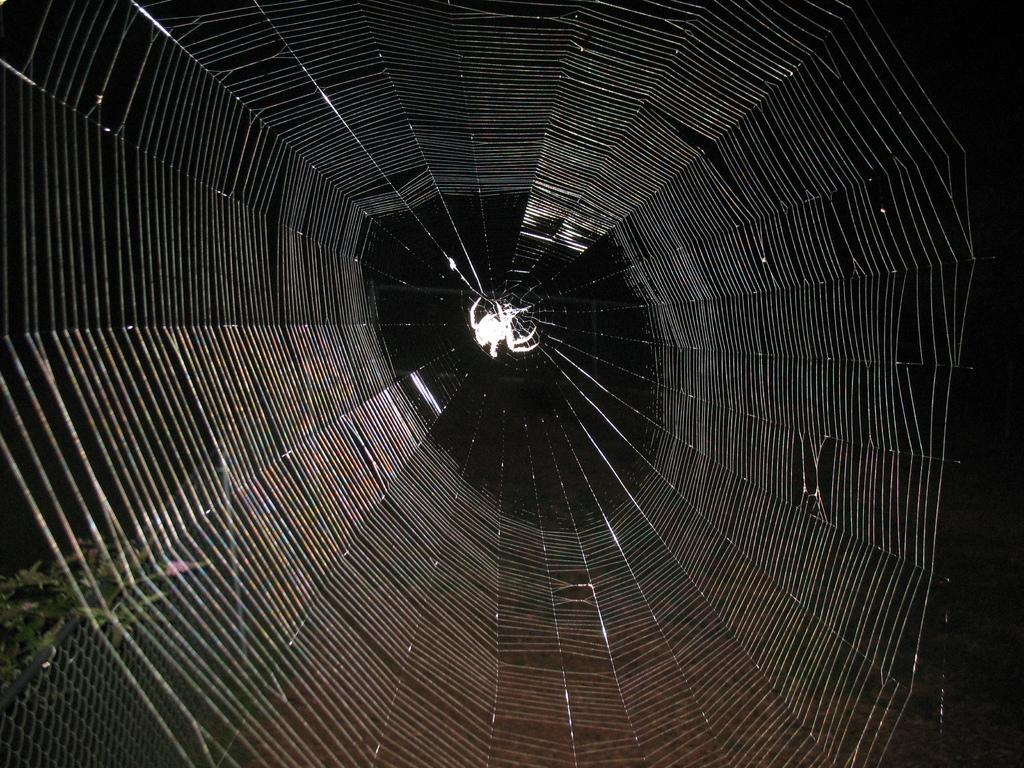What is the main subject of the picture? The main subject of the picture is a spider web. Where is the spider located in the picture? The spider is in the center of the picture. What can be seen on the left side of the picture? There is a plant and fencing on the left side of the picture. How does the spider's aunt communicate with it in the picture? There is no mention of an aunt or any form of communication in the picture. The image only shows a spider web with a spider in the center and a plant and fencing on the left side. 